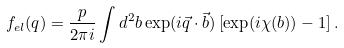<formula> <loc_0><loc_0><loc_500><loc_500>f _ { e l } ( q ) = \frac { p } { 2 \pi i } \int d ^ { 2 } b \exp ( i \vec { q } \cdot \vec { b } ) \left [ \exp ( i \chi ( b ) ) - 1 \right ] .</formula> 